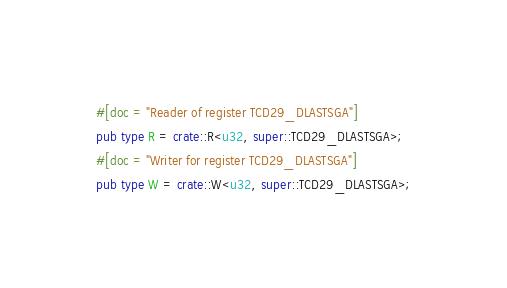<code> <loc_0><loc_0><loc_500><loc_500><_Rust_>#[doc = "Reader of register TCD29_DLASTSGA"]
pub type R = crate::R<u32, super::TCD29_DLASTSGA>;
#[doc = "Writer for register TCD29_DLASTSGA"]
pub type W = crate::W<u32, super::TCD29_DLASTSGA>;</code> 